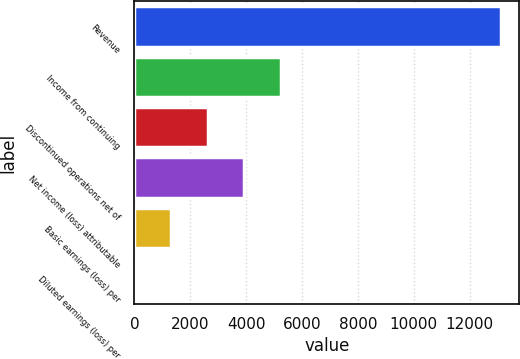Convert chart to OTSL. <chart><loc_0><loc_0><loc_500><loc_500><bar_chart><fcel>Revenue<fcel>Income from continuing<fcel>Discontinued operations net of<fcel>Net income (loss) attributable<fcel>Basic earnings (loss) per<fcel>Diluted earnings (loss) per<nl><fcel>13110<fcel>5244.58<fcel>2622.78<fcel>3933.68<fcel>1311.88<fcel>0.98<nl></chart> 